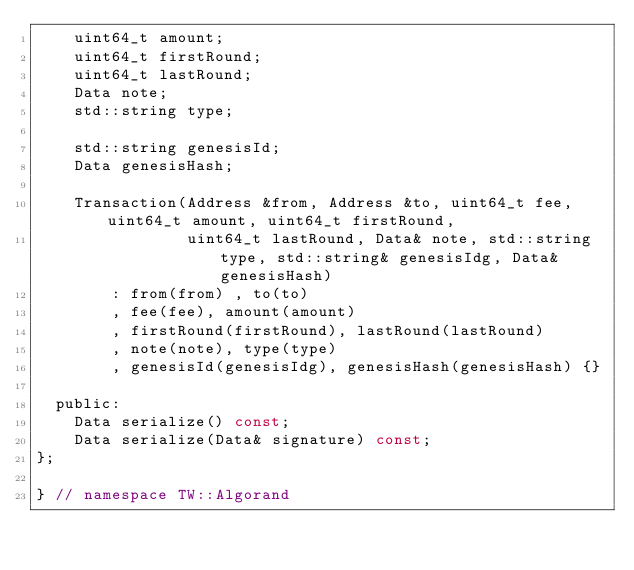Convert code to text. <code><loc_0><loc_0><loc_500><loc_500><_C_>    uint64_t amount;
    uint64_t firstRound;
    uint64_t lastRound;
    Data note;
    std::string type;

    std::string genesisId;
    Data genesisHash;

    Transaction(Address &from, Address &to, uint64_t fee, uint64_t amount, uint64_t firstRound,
                uint64_t lastRound, Data& note, std::string type, std::string& genesisIdg, Data& genesisHash)
        : from(from) , to(to)
        , fee(fee), amount(amount)
        , firstRound(firstRound), lastRound(lastRound)
        , note(note), type(type)
        , genesisId(genesisIdg), genesisHash(genesisHash) {}

  public:
    Data serialize() const;
    Data serialize(Data& signature) const;
};

} // namespace TW::Algorand
</code> 